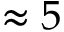<formula> <loc_0><loc_0><loc_500><loc_500>\approx 5</formula> 